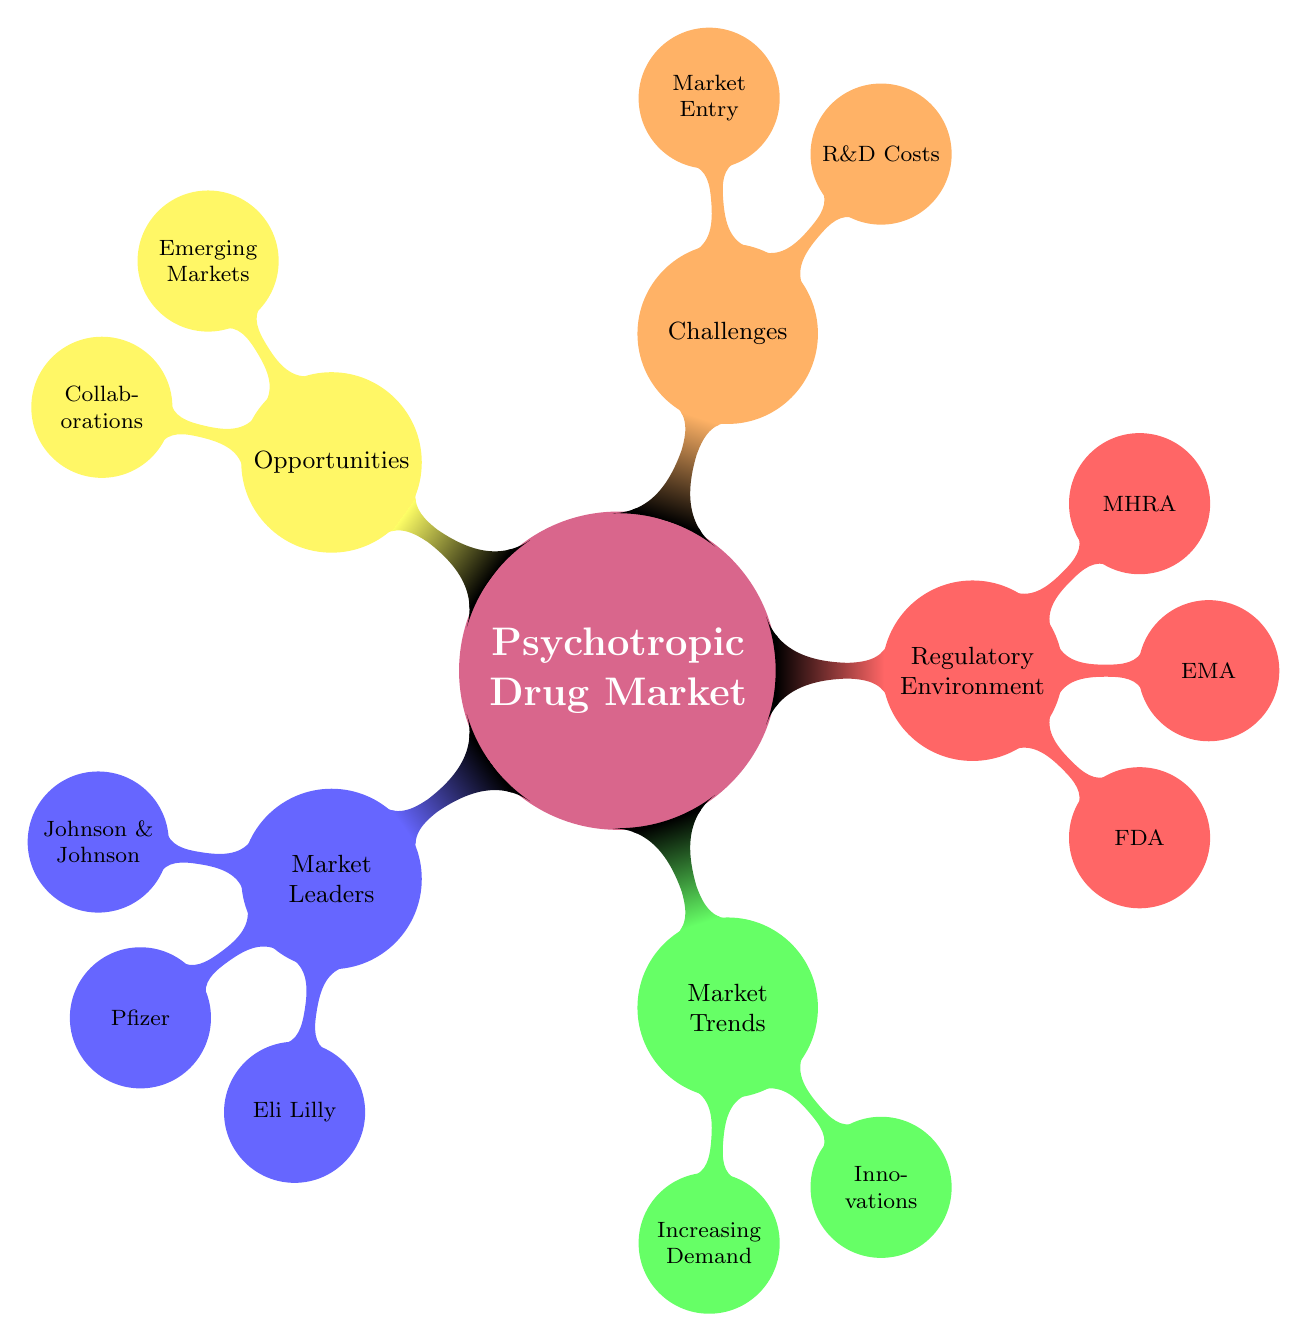What companies are listed as market leaders? The diagram lists three companies under the "Market Leaders" node: Johnson & Johnson, Pfizer, and Eli Lilly.
Answer: Johnson & Johnson, Pfizer, Eli Lilly How many key agencies are noted in the regulatory environment? Under the "Regulatory Environment" node, there are three agencies mentioned: FDA, EMA, and MHRA, thus the total number is three.
Answer: 3 What are two factors that contribute to increasing demand in the market? The "Market Trends" node mentions two factors contributing to increasing demand: Aging Population and Rise in Mental Health Awareness.
Answer: Aging Population, Rise in Mental Health Awareness Which node contains both "High Development Costs" and "Lengthy Approval Processes"? These two challenges are found under the "Challenges" node, which indicates that they are related to R&D Costs.
Answer: Challenges Which companies have products listed under market leaders, and what are their top products? Under the "Market Leaders" node, companies and their top products are listed: Johnson & Johnson with Risperdal, Pfizer with Zoloft, and Eli Lilly with Prozac.
Answer: Johnson & Johnson - Risperdal, Pfizer - Zoloft, Eli Lilly - Prozac What kinds of opportunities are highlighted in the diagram? The "Opportunities" node lists Emerging Markets and Collaborations as types of opportunities available in the market.
Answer: Emerging Markets, Collaborations How does the length of approval processes impact market entry? Lengthy approval processes are listed under "Challenges," indicating they pose a significant obstacle to market entry, especially for new products.
Answer: Lengthy Approval Processes Which emerging markets are identified in the opportunities section? The "Emerging Markets" under Opportunities mentions Asia-Pacific and Latin America, as important regions for expansion.
Answer: Asia-Pacific, Latin America 